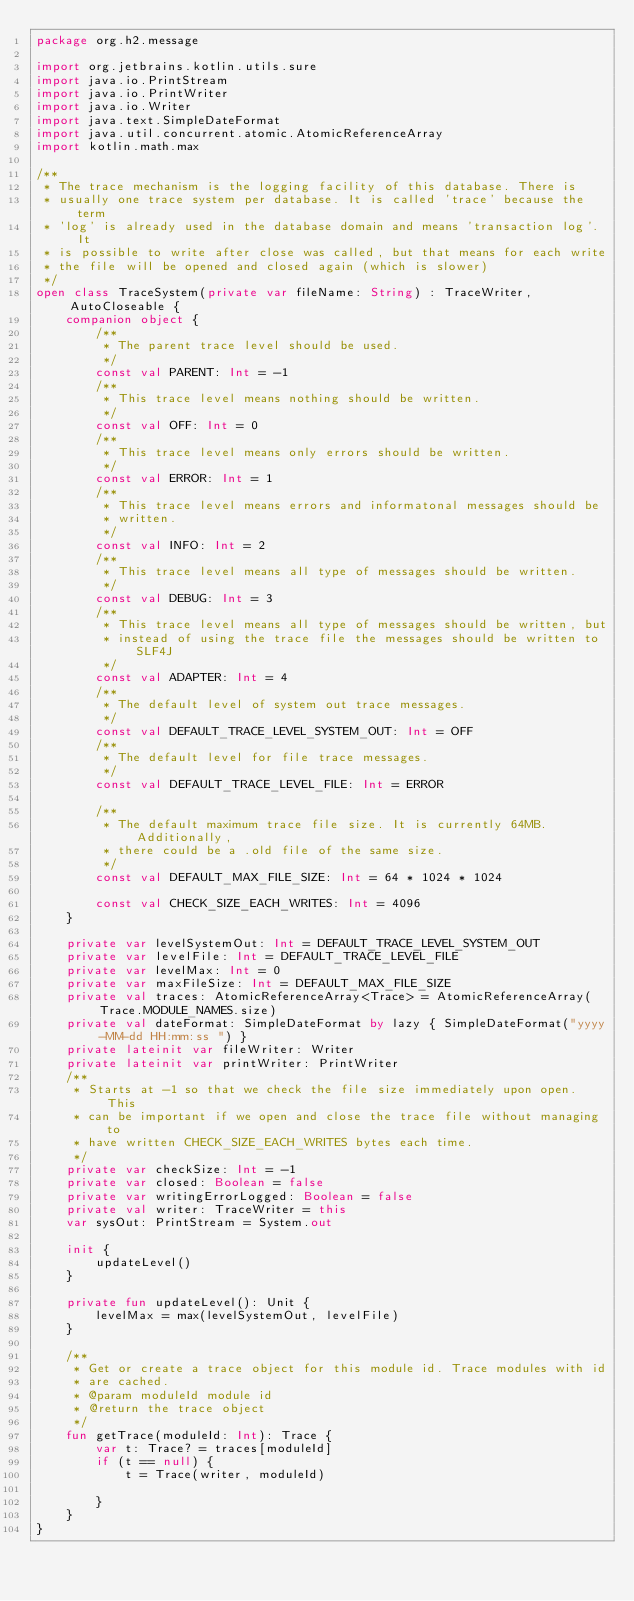<code> <loc_0><loc_0><loc_500><loc_500><_Kotlin_>package org.h2.message

import org.jetbrains.kotlin.utils.sure
import java.io.PrintStream
import java.io.PrintWriter
import java.io.Writer
import java.text.SimpleDateFormat
import java.util.concurrent.atomic.AtomicReferenceArray
import kotlin.math.max

/**
 * The trace mechanism is the logging facility of this database. There is
 * usually one trace system per database. It is called 'trace' because the term
 * 'log' is already used in the database domain and means 'transaction log'. It
 * is possible to write after close was called, but that means for each write
 * the file will be opened and closed again (which is slower)
 */
open class TraceSystem(private var fileName: String) : TraceWriter, AutoCloseable {
    companion object {
        /**
         * The parent trace level should be used.
         */
        const val PARENT: Int = -1
        /**
         * This trace level means nothing should be written.
         */
        const val OFF: Int = 0
        /**
         * This trace level means only errors should be written.
         */
        const val ERROR: Int = 1
        /**
         * This trace level means errors and informatonal messages should be
         * written.
         */
        const val INFO: Int = 2
        /**
         * This trace level means all type of messages should be written.
         */
        const val DEBUG: Int = 3
        /**
         * This trace level means all type of messages should be written, but
         * instead of using the trace file the messages should be written to SLF4J
         */
        const val ADAPTER: Int = 4
        /**
         * The default level of system out trace messages.
         */
        const val DEFAULT_TRACE_LEVEL_SYSTEM_OUT: Int = OFF
        /**
         * The default level for file trace messages.
         */
        const val DEFAULT_TRACE_LEVEL_FILE: Int = ERROR

        /**
         * The default maximum trace file size. It is currently 64MB. Additionally,
         * there could be a .old file of the same size.
         */
        const val DEFAULT_MAX_FILE_SIZE: Int = 64 * 1024 * 1024

        const val CHECK_SIZE_EACH_WRITES: Int = 4096
    }

    private var levelSystemOut: Int = DEFAULT_TRACE_LEVEL_SYSTEM_OUT
    private var levelFile: Int = DEFAULT_TRACE_LEVEL_FILE
    private var levelMax: Int = 0
    private var maxFileSize: Int = DEFAULT_MAX_FILE_SIZE
    private val traces: AtomicReferenceArray<Trace> = AtomicReferenceArray(Trace.MODULE_NAMES.size)
    private val dateFormat: SimpleDateFormat by lazy { SimpleDateFormat("yyyy-MM-dd HH:mm:ss ") }
    private lateinit var fileWriter: Writer
    private lateinit var printWriter: PrintWriter
    /**
     * Starts at -1 so that we check the file size immediately upon open. This
     * can be important if we open and close the trace file without managing to
     * have written CHECK_SIZE_EACH_WRITES bytes each time.
     */
    private var checkSize: Int = -1
    private var closed: Boolean = false
    private var writingErrorLogged: Boolean = false
    private val writer: TraceWriter = this
    var sysOut: PrintStream = System.out

    init {
        updateLevel()
    }

    private fun updateLevel(): Unit {
        levelMax = max(levelSystemOut, levelFile)
    }

    /**
     * Get or create a trace object for this module id. Trace modules with id
     * are cached.
     * @param moduleId module id
     * @return the trace object
     */
    fun getTrace(moduleId: Int): Trace {
        var t: Trace? = traces[moduleId]
        if (t == null) {
            t = Trace(writer, moduleId)

        }
    }
}</code> 